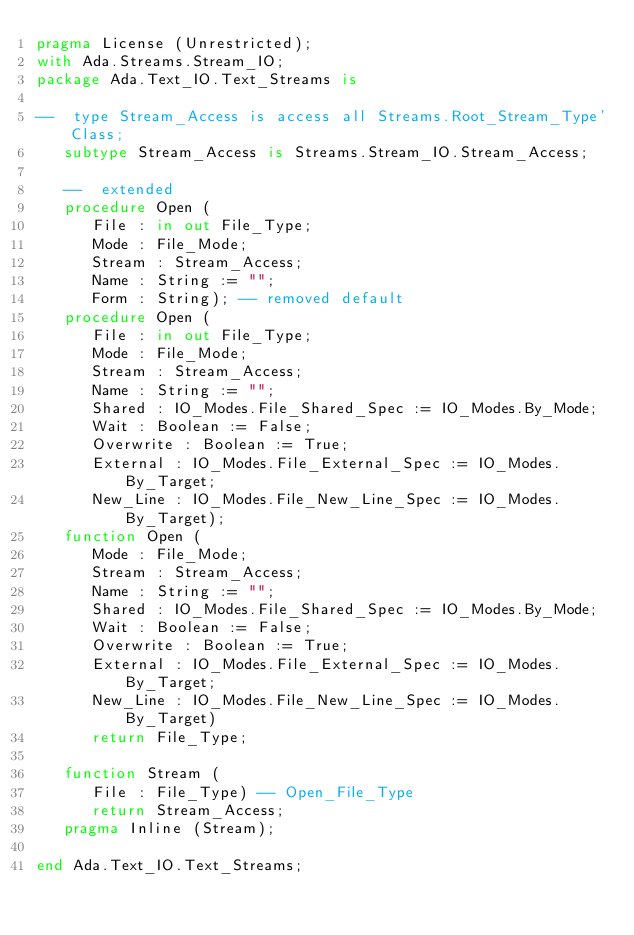Convert code to text. <code><loc_0><loc_0><loc_500><loc_500><_Ada_>pragma License (Unrestricted);
with Ada.Streams.Stream_IO;
package Ada.Text_IO.Text_Streams is

--  type Stream_Access is access all Streams.Root_Stream_Type'Class;
   subtype Stream_Access is Streams.Stream_IO.Stream_Access;

   --  extended
   procedure Open (
      File : in out File_Type;
      Mode : File_Mode;
      Stream : Stream_Access;
      Name : String := "";
      Form : String); -- removed default
   procedure Open (
      File : in out File_Type;
      Mode : File_Mode;
      Stream : Stream_Access;
      Name : String := "";
      Shared : IO_Modes.File_Shared_Spec := IO_Modes.By_Mode;
      Wait : Boolean := False;
      Overwrite : Boolean := True;
      External : IO_Modes.File_External_Spec := IO_Modes.By_Target;
      New_Line : IO_Modes.File_New_Line_Spec := IO_Modes.By_Target);
   function Open (
      Mode : File_Mode;
      Stream : Stream_Access;
      Name : String := "";
      Shared : IO_Modes.File_Shared_Spec := IO_Modes.By_Mode;
      Wait : Boolean := False;
      Overwrite : Boolean := True;
      External : IO_Modes.File_External_Spec := IO_Modes.By_Target;
      New_Line : IO_Modes.File_New_Line_Spec := IO_Modes.By_Target)
      return File_Type;

   function Stream (
      File : File_Type) -- Open_File_Type
      return Stream_Access;
   pragma Inline (Stream);

end Ada.Text_IO.Text_Streams;
</code> 